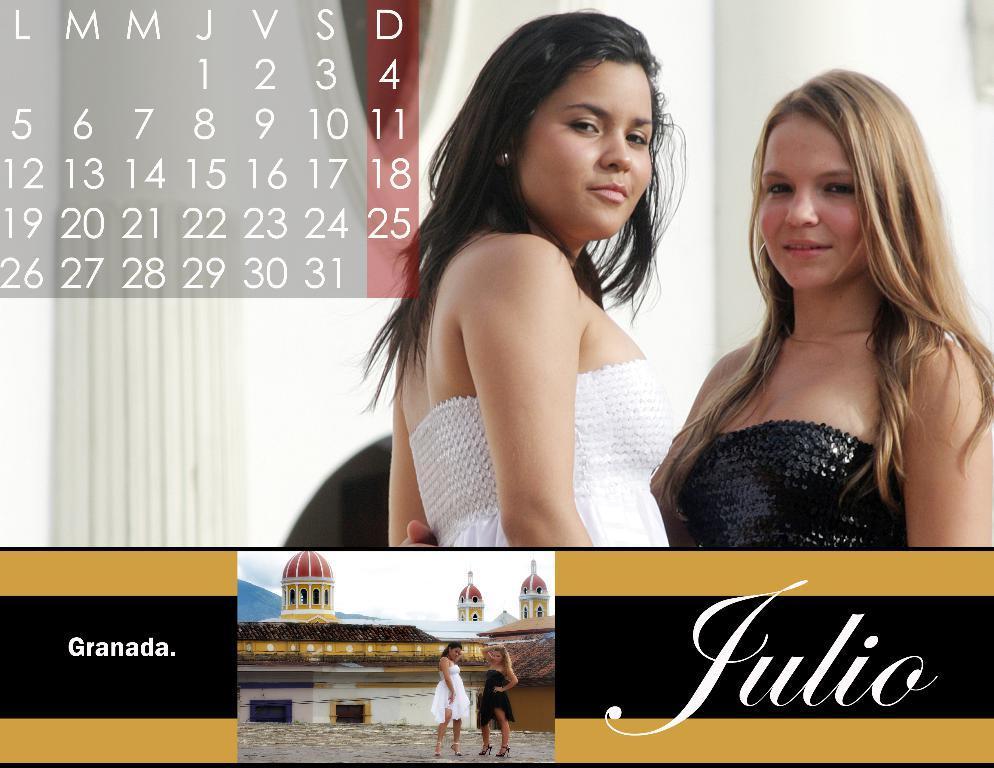In one or two sentences, can you explain what this image depicts? This is an image with collage. In this image we can see two women holding each other. We can also see some numerical calendar sheet and some text edited on it. On the bottom of the image we can see the picture of two women standing. On the backside we can see some buildings with windows, the hills and the sky. 